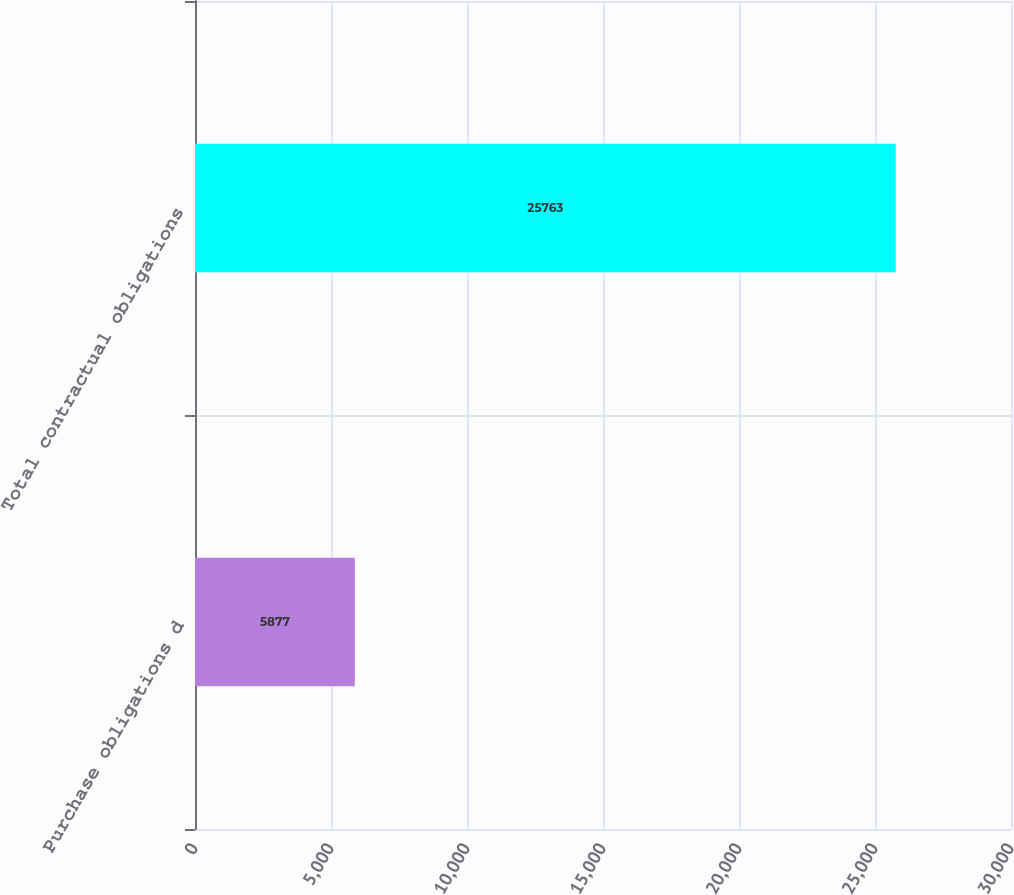Convert chart to OTSL. <chart><loc_0><loc_0><loc_500><loc_500><bar_chart><fcel>Purchase obligations d<fcel>Total contractual obligations<nl><fcel>5877<fcel>25763<nl></chart> 